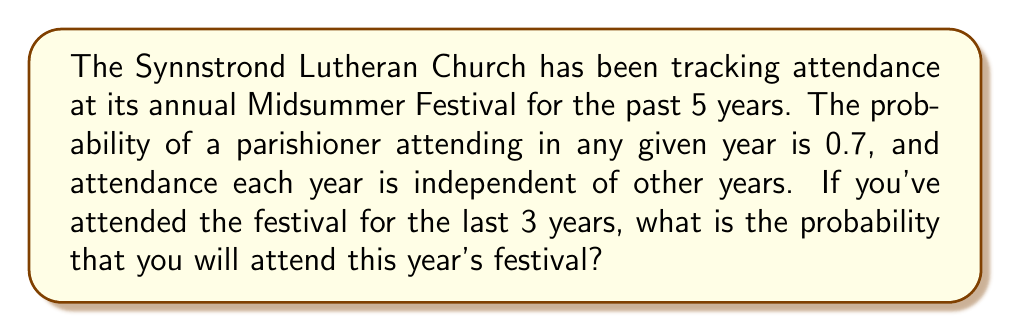Help me with this question. Let's approach this step-by-step:

1) First, we need to understand what the question is asking. We're looking for the probability of attending this year's festival, given that you've attended for the past 3 years.

2) The key information given is:
   - The probability of attending in any given year is 0.7
   - Attendance each year is independent of other years

3) Since the events are independent, your past attendance doesn't actually affect the probability of your attendance this year. This is a crucial point in probability theory known as independence.

4) Therefore, the probability of attending this year is simply the probability of attending in any given year, which is 0.7.

5) We can express this mathematically as:

   $$P(\text{Attend this year} | \text{Attended last 3 years}) = P(\text{Attend this year}) = 0.7$$

   Where the vertical bar "|" means "given that".

6) It's worth noting that if the events were not independent, we would need to use Bayes' theorem to calculate the conditional probability. But in this case, the independence of events simplifies our calculation significantly.
Answer: $0.7$ 